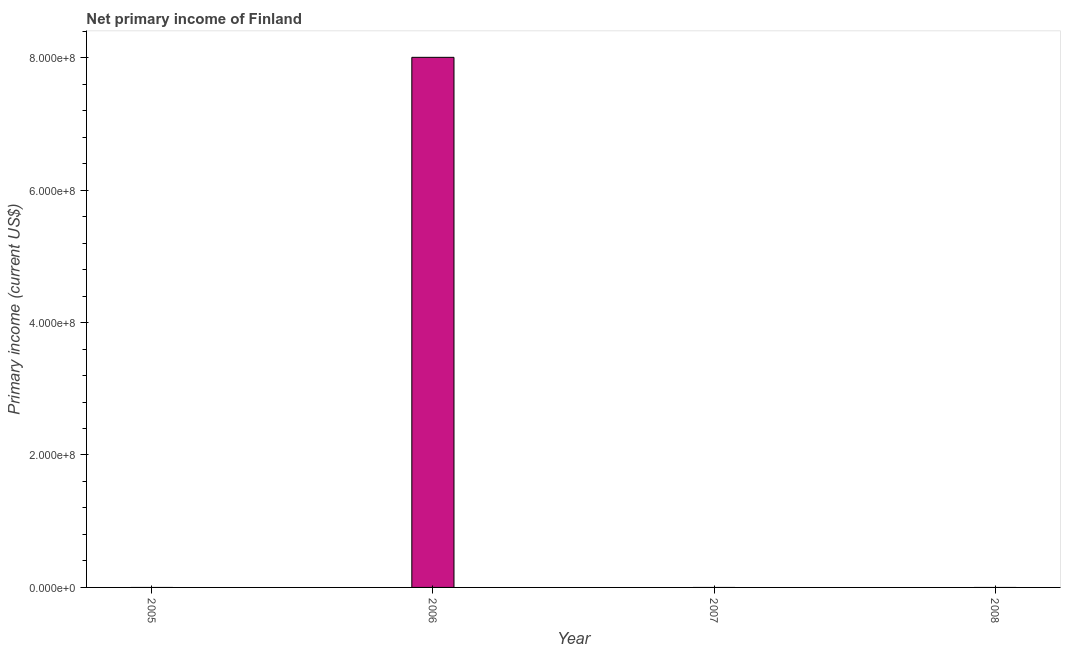What is the title of the graph?
Make the answer very short. Net primary income of Finland. What is the label or title of the X-axis?
Your answer should be very brief. Year. What is the label or title of the Y-axis?
Offer a terse response. Primary income (current US$). Across all years, what is the maximum amount of primary income?
Ensure brevity in your answer.  8.01e+08. In which year was the amount of primary income maximum?
Your answer should be very brief. 2006. What is the sum of the amount of primary income?
Ensure brevity in your answer.  8.01e+08. What is the average amount of primary income per year?
Provide a short and direct response. 2.00e+08. What is the difference between the highest and the lowest amount of primary income?
Provide a succinct answer. 8.01e+08. In how many years, is the amount of primary income greater than the average amount of primary income taken over all years?
Your answer should be compact. 1. What is the difference between two consecutive major ticks on the Y-axis?
Offer a terse response. 2.00e+08. What is the Primary income (current US$) of 2006?
Keep it short and to the point. 8.01e+08. What is the Primary income (current US$) in 2007?
Provide a succinct answer. 0. 